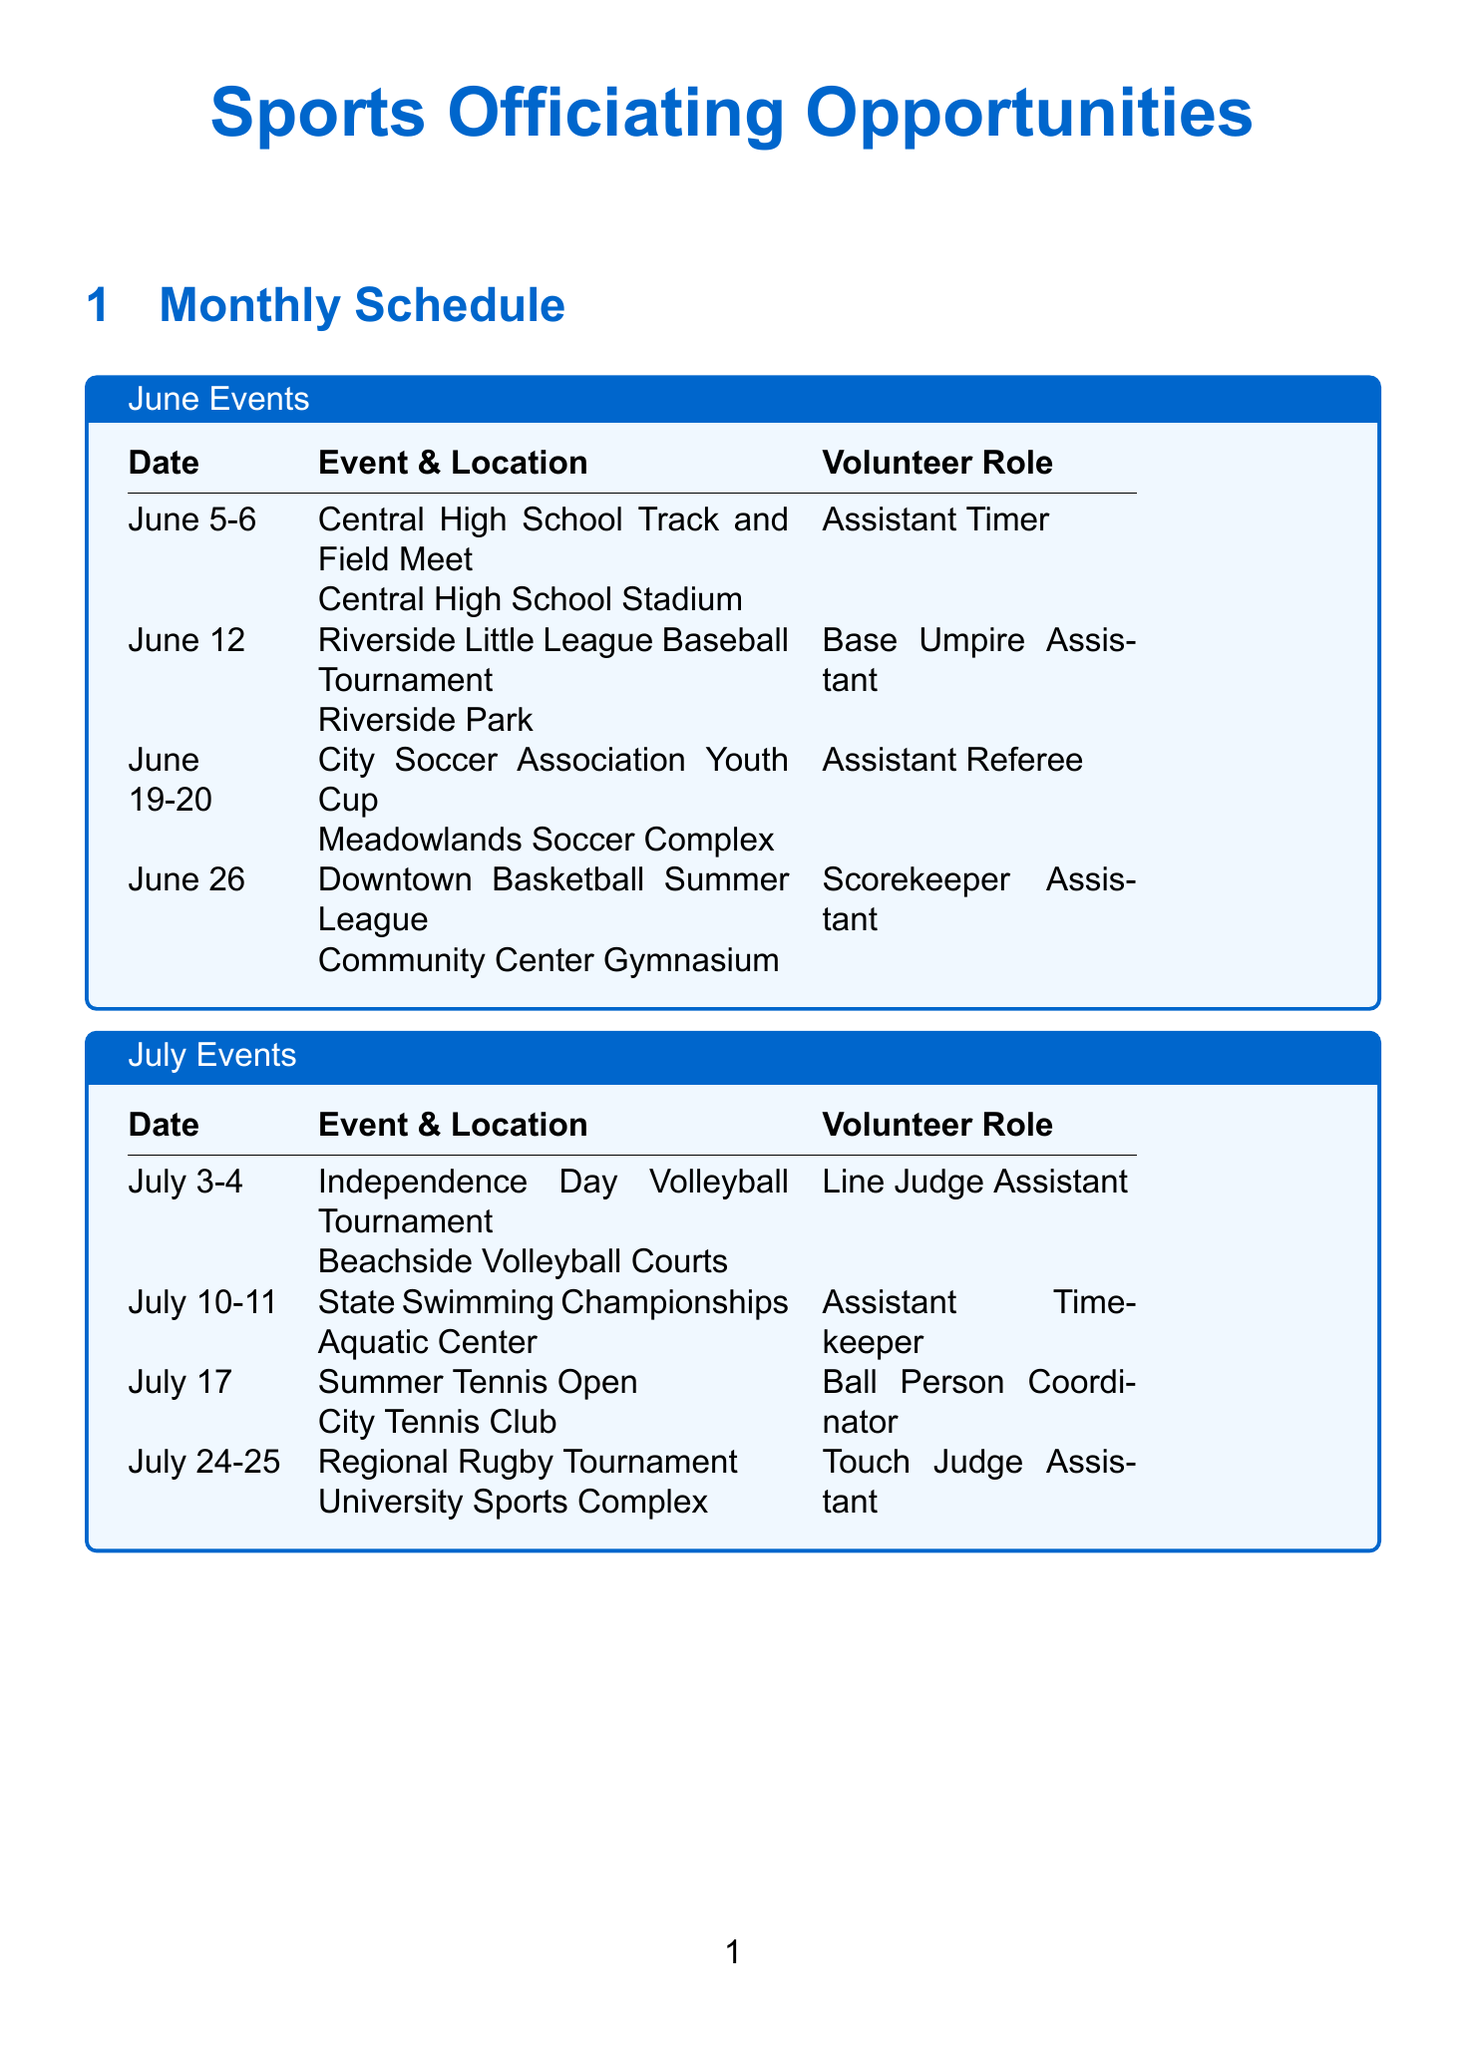what is the date of the City Soccer Association Youth Cup? The City Soccer Association Youth Cup takes place on June 19-20.
Answer: June 19-20 who is the contact for the Riverside Little League Baseball Tournament? The contact for the Riverside Little League Baseball Tournament is Mike Thompson.
Answer: Mike Thompson what volunteer role is needed for the State Swimming Championships? The volunteer role needed for the State Swimming Championships is Assistant Timekeeper.
Answer: Assistant Timekeeper which month has a workshop on Conflict Resolution for Sports Officials? The workshop on Conflict Resolution for Sports Officials is scheduled for August, specifically August 10.
Answer: August how many events are listed for July? There are four events listed for July.
Answer: Four which organization is associated with James Wilson? James Wilson is associated with the City Umpires Association.
Answer: City Umpires Association what venue hosts the Summer Basketball Showcase? The Summer Basketball Showcase is hosted at the Sports Arena.
Answer: Sports Arena which workshop is taking place in June? The workshop taking place in June is "Introduction to Sports Officiating."
Answer: Introduction to Sports Officiating who is the instructor for the workshop on Rules and Regulations in Youth Sports? The instructor for the workshop on Rules and Regulations in Youth Sports is Maria Rodriguez.
Answer: Maria Rodriguez 